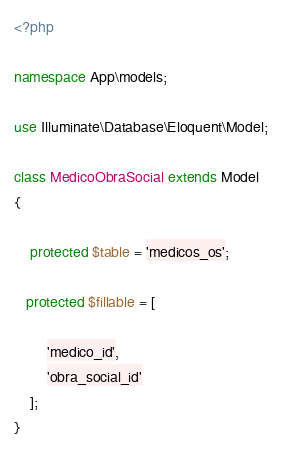Convert code to text. <code><loc_0><loc_0><loc_500><loc_500><_PHP_><?php

namespace App\models;

use Illuminate\Database\Eloquent\Model;

class MedicoObraSocial extends Model
{
    
    protected $table = 'medicos_os';

   protected $fillable = [
       
        'medico_id',
        'obra_social_id'        
    ];
}
</code> 